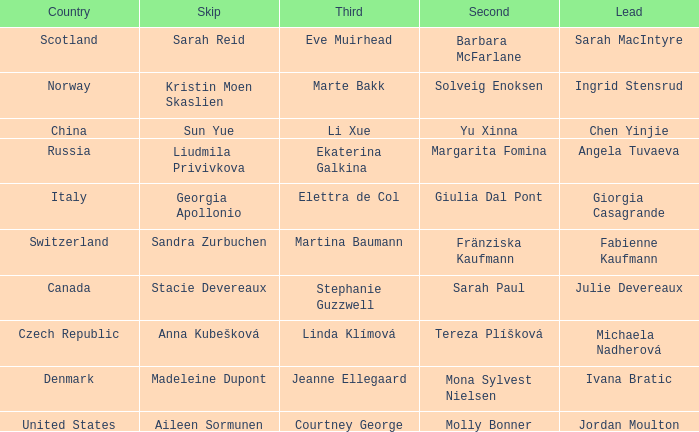In which skip is the country specified as norway? Kristin Moen Skaslien. 